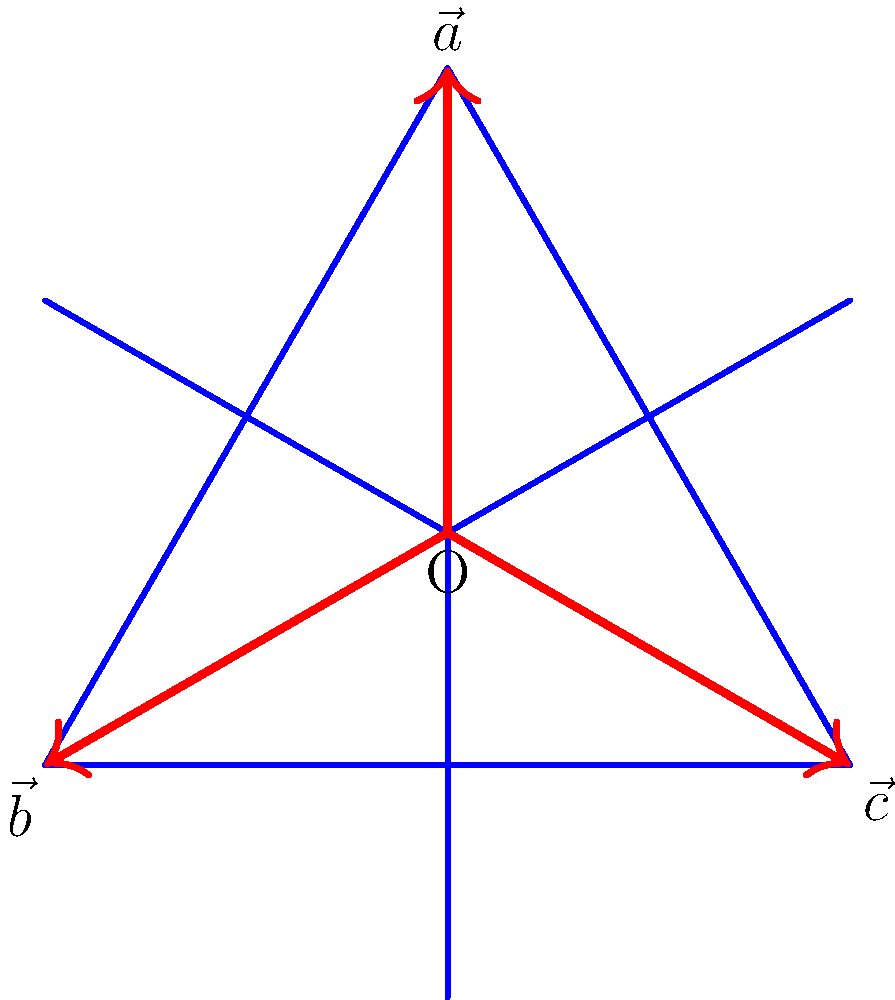In the Star of David shown above, three vectors $\vec{a}$, $\vec{b}$, and $\vec{c}$ form the star's points from the center O. If $\vec{a} = (0, 1)$, express $\vec{b}$ and $\vec{c}$ in terms of their x and y components. To solve this problem, we'll follow these steps:

1) First, recall that the Star of David is formed by two equilateral triangles. The vectors $\vec{a}$, $\vec{b}$, and $\vec{c}$ are separated by 120° angles.

2) We're given that $\vec{a} = (0, 1)$. This vector points straight up.

3) To find $\vec{b}$ and $\vec{c}$, we need to rotate $\vec{a}$ by 120° and 240° respectively.

4) The rotation matrix for angle $\theta$ is:
   $$\begin{pmatrix} \cos\theta & -\sin\theta \\ \sin\theta & \cos\theta \end{pmatrix}$$

5) For $\vec{b}$, we rotate by 120° or $\frac{2\pi}{3}$:
   $$\vec{b} = \begin{pmatrix} \cos\frac{2\pi}{3} & -\sin\frac{2\pi}{3} \\ \sin\frac{2\pi}{3} & \cos\frac{2\pi}{3} \end{pmatrix} \begin{pmatrix} 0 \\ 1 \end{pmatrix}$$

6) Simplify:
   $$\vec{b} = \begin{pmatrix} -\frac{1}{2} \\ -\frac{\sqrt{3}}{2} \end{pmatrix} = (-\frac{\sqrt{3}}{2}, -\frac{1}{2})$$

7) For $\vec{c}$, we rotate by 240° or $\frac{4\pi}{3}$:
   $$\vec{c} = \begin{pmatrix} \cos\frac{4\pi}{3} & -\sin\frac{4\pi}{3} \\ \sin\frac{4\pi}{3} & \cos\frac{4\pi}{3} \end{pmatrix} \begin{pmatrix} 0 \\ 1 \end{pmatrix}$$

8) Simplify:
   $$\vec{c} = \begin{pmatrix} -\frac{1}{2} \\ \frac{\sqrt{3}}{2} \end{pmatrix} = (\frac{\sqrt{3}}{2}, -\frac{1}{2})$$

Thus, we have expressed $\vec{b}$ and $\vec{c}$ in terms of their x and y components.
Answer: $\vec{b} = (-\frac{\sqrt{3}}{2}, -\frac{1}{2})$, $\vec{c} = (\frac{\sqrt{3}}{2}, -\frac{1}{2})$ 